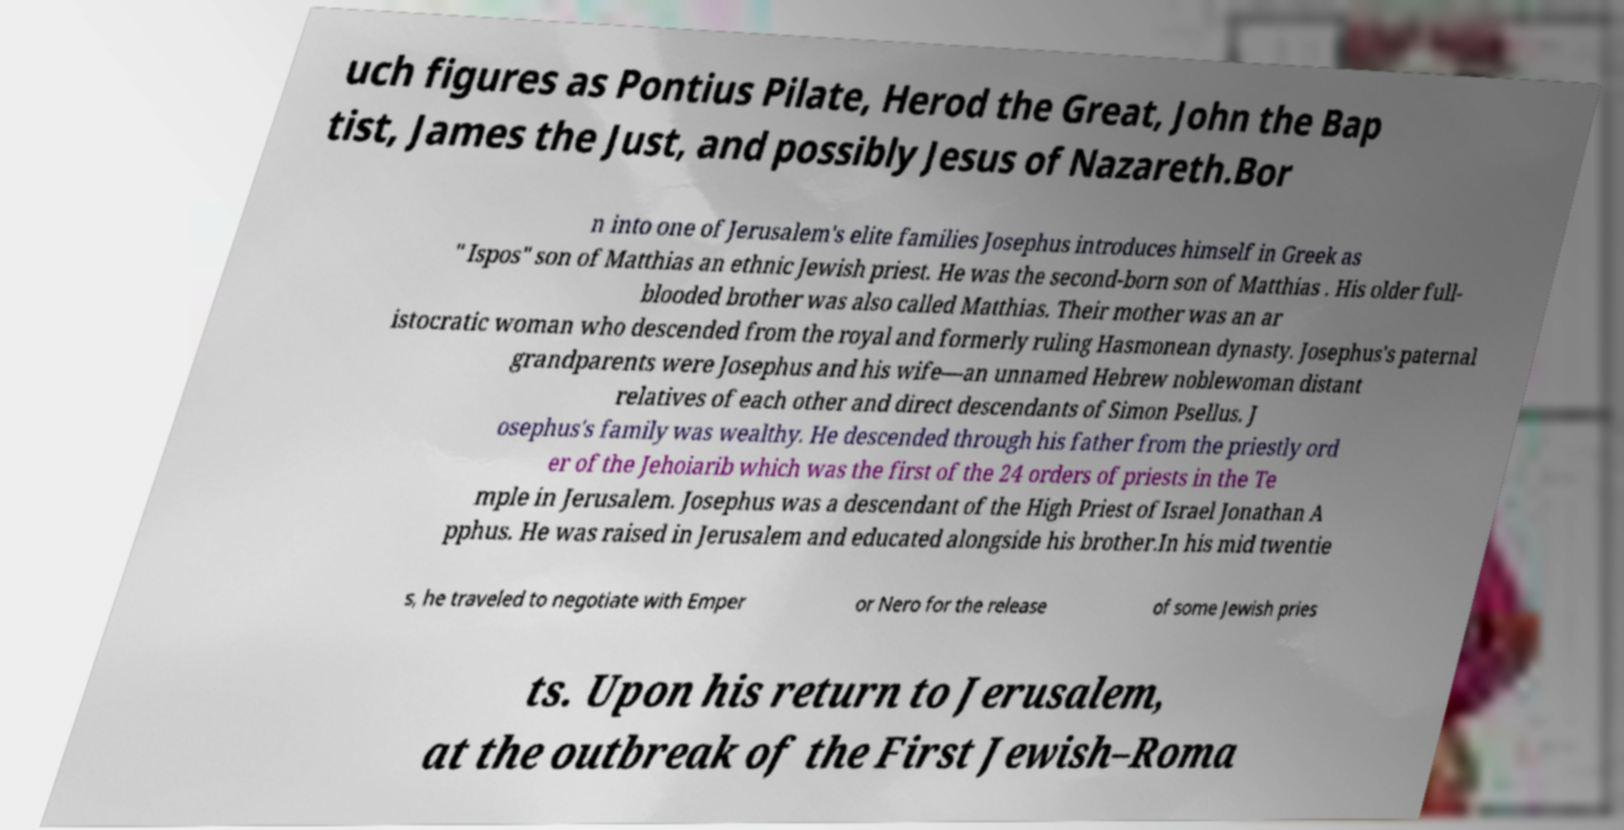I need the written content from this picture converted into text. Can you do that? uch figures as Pontius Pilate, Herod the Great, John the Bap tist, James the Just, and possibly Jesus of Nazareth.Bor n into one of Jerusalem's elite families Josephus introduces himself in Greek as " Ispos" son of Matthias an ethnic Jewish priest. He was the second-born son of Matthias . His older full- blooded brother was also called Matthias. Their mother was an ar istocratic woman who descended from the royal and formerly ruling Hasmonean dynasty. Josephus's paternal grandparents were Josephus and his wife—an unnamed Hebrew noblewoman distant relatives of each other and direct descendants of Simon Psellus. J osephus's family was wealthy. He descended through his father from the priestly ord er of the Jehoiarib which was the first of the 24 orders of priests in the Te mple in Jerusalem. Josephus was a descendant of the High Priest of Israel Jonathan A pphus. He was raised in Jerusalem and educated alongside his brother.In his mid twentie s, he traveled to negotiate with Emper or Nero for the release of some Jewish pries ts. Upon his return to Jerusalem, at the outbreak of the First Jewish–Roma 